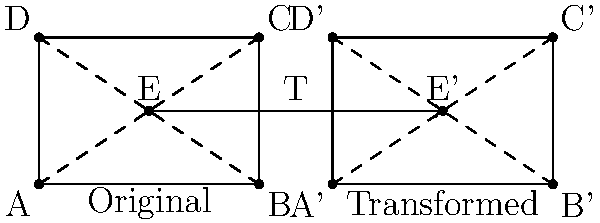In a family photo, you want to be perfectly centered. The panoramic photo is represented by the rectangle ABCD, where you are currently at point E. To achieve the perfect composition, the photo needs to undergo a transformation T that moves you to the center of the new photo A'B'C'D'. If T is a combination of a translation and a dilation, what is the scale factor of the dilation? Let's approach this step-by-step:

1) First, we need to identify the center of the original photo and the transformed photo:
   - Original center: $(\frac{6}{2}, \frac{4}{2}) = (3, 2)$
   - Transformed center: $(\frac{14}{2}, \frac{4}{2}) = (7, 2)$

2) We're told that you are at point E in the original photo, which is already at (3, 2), the center of the original photo.

3) The transformation T moves E to E', which is at (11, 2), the center of the new photo.

4) The translation component of T moves the center from (3, 2) to (7, 2), a shift of 4 units to the right.

5) After the translation, a dilation is applied. To find the scale factor:
   - Original width: 6 units (from 0 to 6 on x-axis)
   - New width: 6 units (from 8 to 14 on x-axis)

6) Since the width remains unchanged after the transformation, the scale factor of the dilation must be 1.

Therefore, the transformation T consists of a translation 4 units to the right, followed by a dilation with a scale factor of 1 (which effectively does nothing).
Answer: 1 